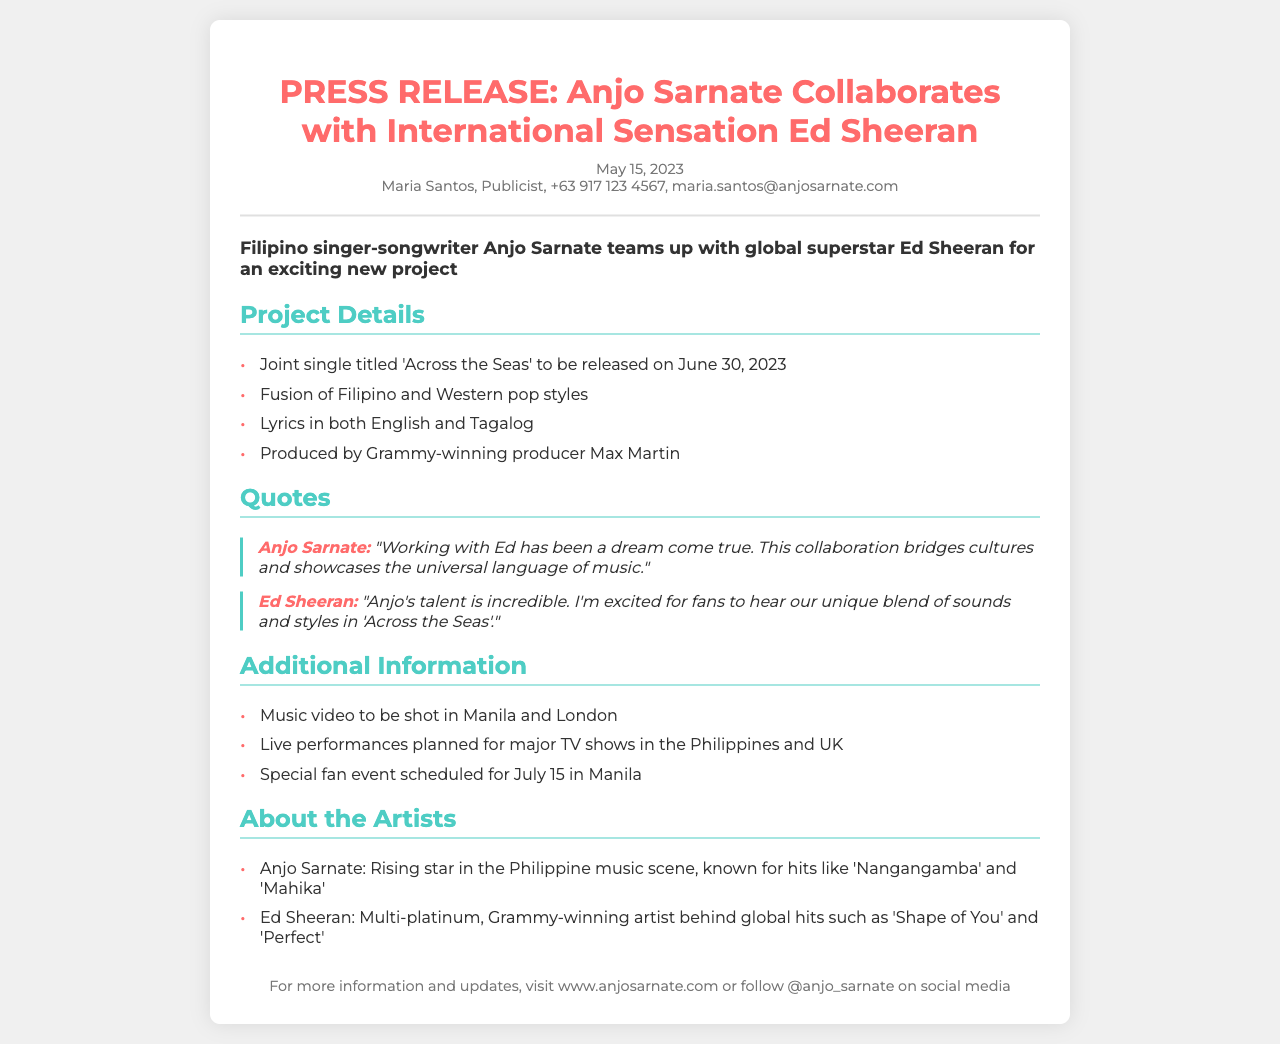What is the title of the joint single? The title of the joint single is mentioned in the "Project Details" section as 'Across the Seas'.
Answer: Across the Seas Who is producing the single? The document states that the single is produced by Grammy-winning producer Max Martin.
Answer: Max Martin What is the release date of the joint single? The document specifies that the release date for the joint single is June 30, 2023.
Answer: June 30, 2023 Which two locations will the music video be shot? The "Additional Information" section lists the music video being shot in Manila and London.
Answer: Manila and London What genre does the joint single combine? The document describes the project as a fusion of Filipino and Western pop styles.
Answer: Filipino and Western pop styles What do Anjo Sarnate and Ed Sheeran highlight about their collaboration? Both artists emphasize the cultural bridge and unique blend of sounds in their quotes.
Answer: Cultural bridge and unique blend of sounds When is the special fan event scheduled? The document notes that the special fan event is scheduled for July 15 in Manila.
Answer: July 15 Who is Anjo Sarnate? The "About the Artists" section provides information that Anjo Sarnate is a rising star in the Philippine music scene.
Answer: Rising star in the Philippine music scene What is the purpose of this document? This document is a press release announcing the collaboration between Anjo Sarnate and Ed Sheeran.
Answer: Announcing the collaboration 